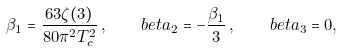Convert formula to latex. <formula><loc_0><loc_0><loc_500><loc_500>\beta _ { 1 } = \frac { 6 3 \zeta ( 3 ) } { 8 0 \pi ^ { 2 } T _ { c } ^ { 2 } } \, , \quad b e t a _ { 2 } = - \frac { \beta _ { 1 } } { 3 } \, , \quad b e t a _ { 3 } = 0 ,</formula> 